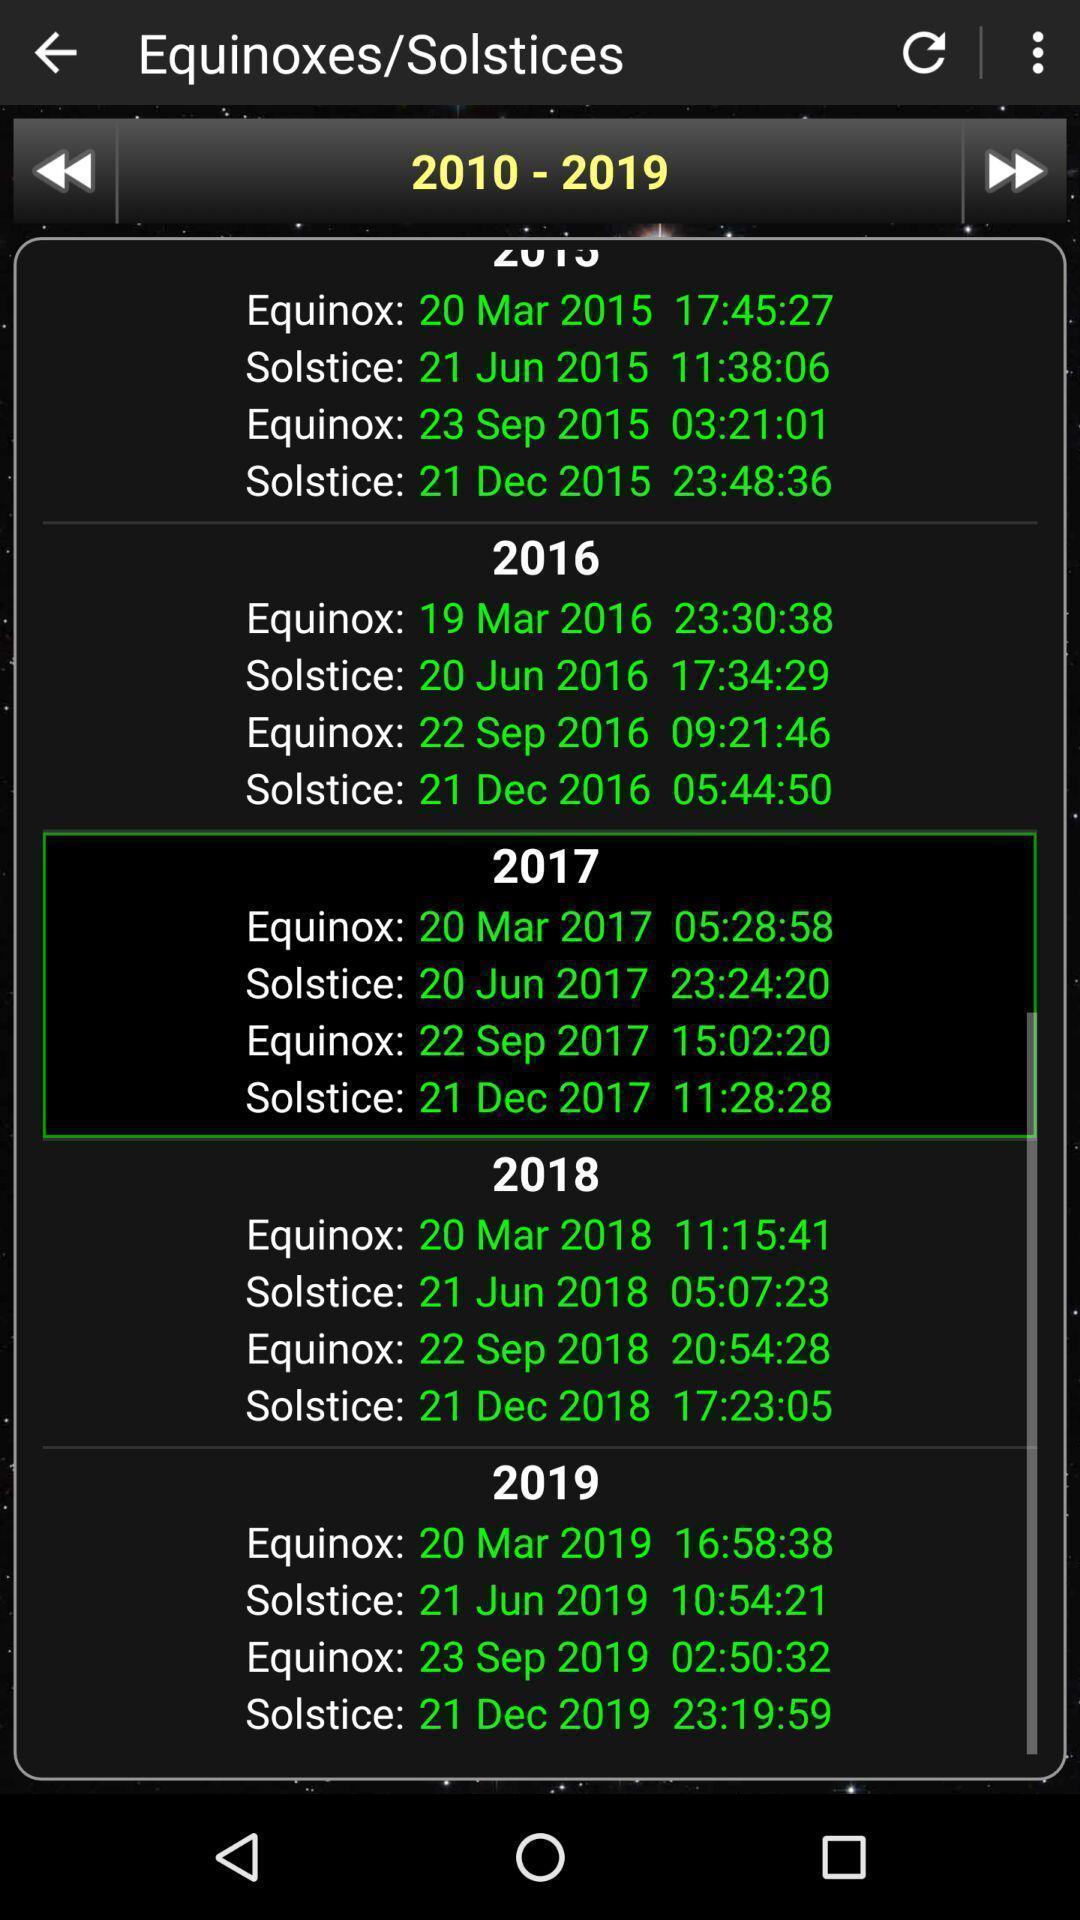Describe the visual elements of this screenshot. Social app for showing solistices. 